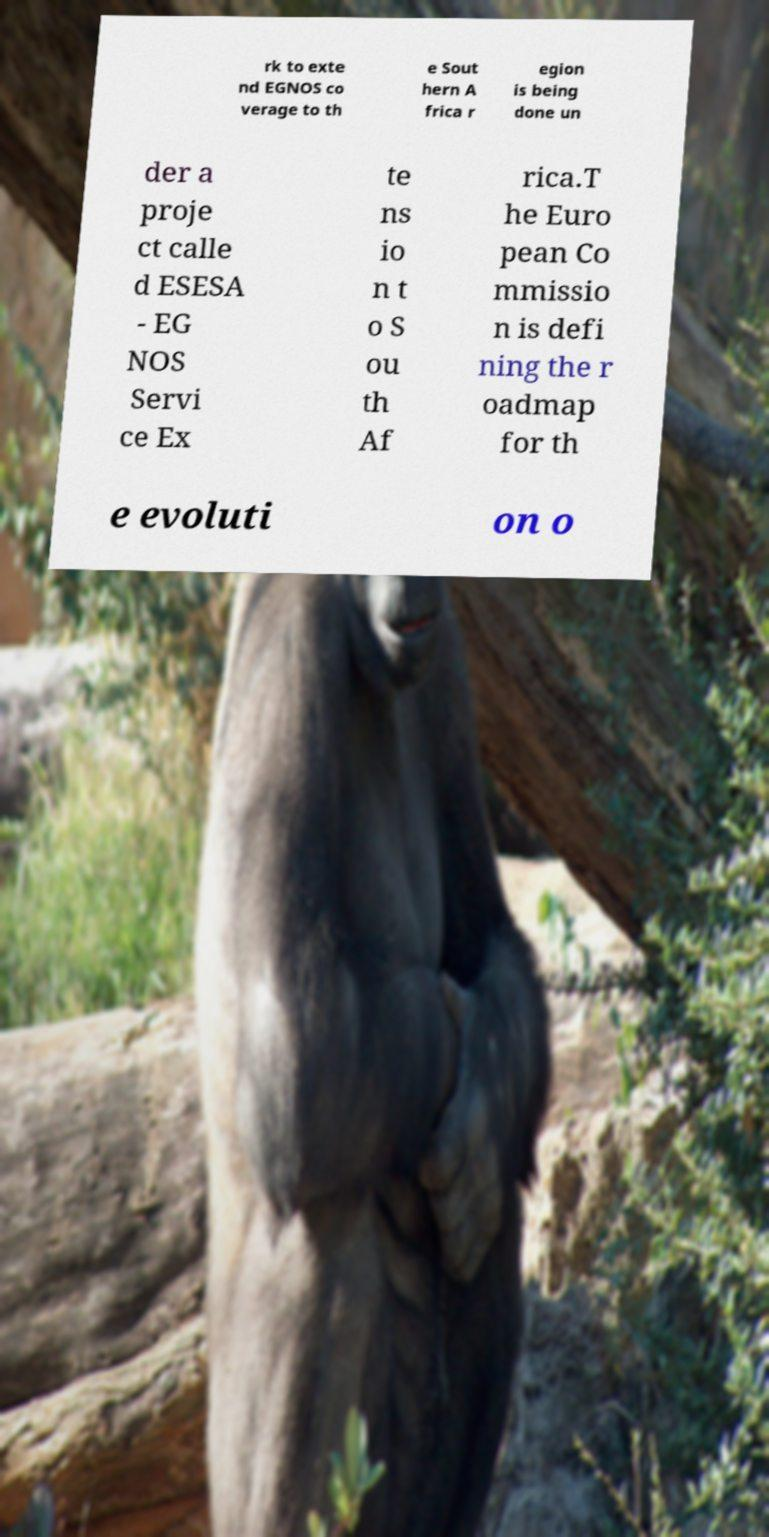Please read and relay the text visible in this image. What does it say? rk to exte nd EGNOS co verage to th e Sout hern A frica r egion is being done un der a proje ct calle d ESESA - EG NOS Servi ce Ex te ns io n t o S ou th Af rica.T he Euro pean Co mmissio n is defi ning the r oadmap for th e evoluti on o 